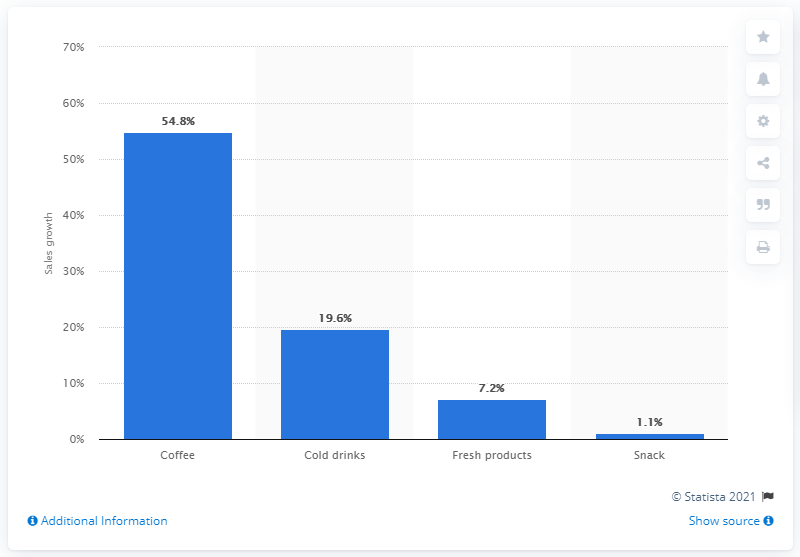Highlight a few significant elements in this photo. In 2016, the sales of coffee through vending machines increased by 54.8%. 